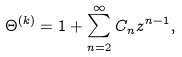<formula> <loc_0><loc_0><loc_500><loc_500>\Theta ^ { ( k ) } = 1 + \sum _ { n = 2 } ^ { \infty } C _ { n } z ^ { n - 1 } ,</formula> 